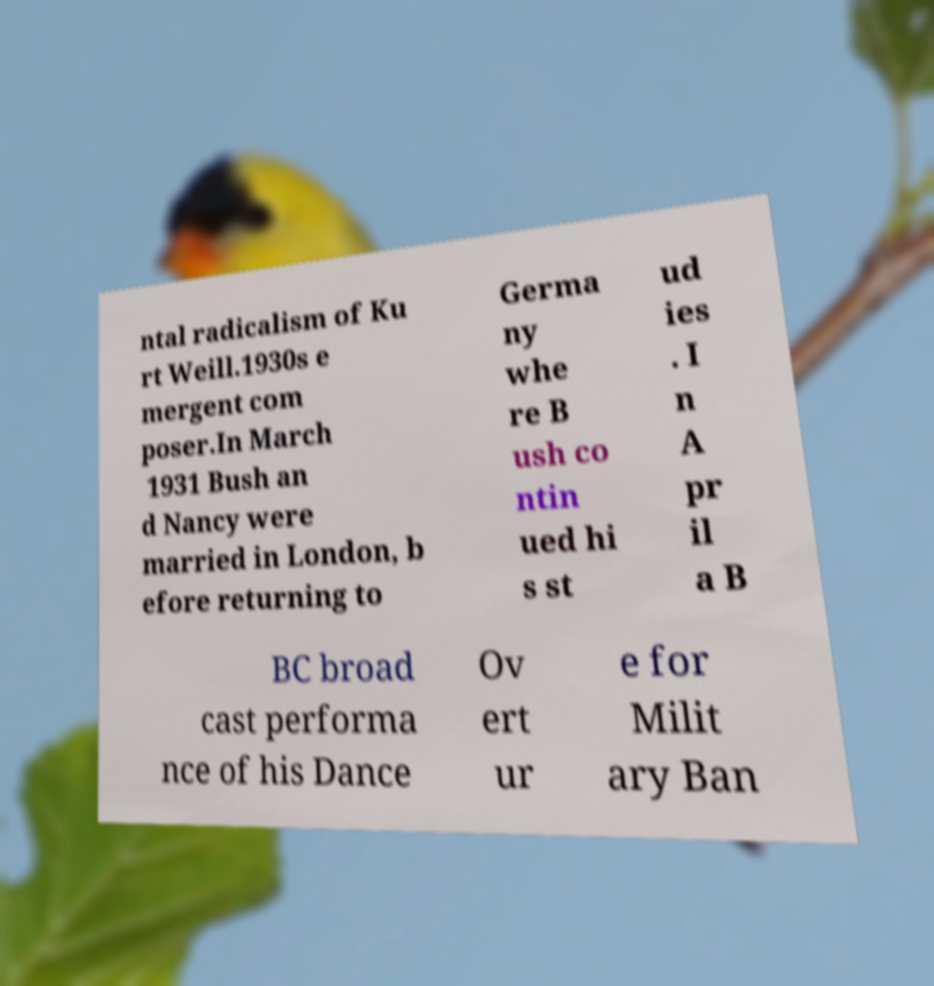Can you accurately transcribe the text from the provided image for me? ntal radicalism of Ku rt Weill.1930s e mergent com poser.In March 1931 Bush an d Nancy were married in London, b efore returning to Germa ny whe re B ush co ntin ued hi s st ud ies . I n A pr il a B BC broad cast performa nce of his Dance Ov ert ur e for Milit ary Ban 